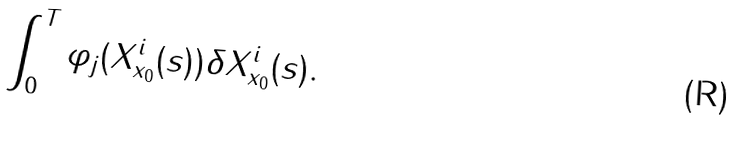<formula> <loc_0><loc_0><loc_500><loc_500>\int _ { 0 } ^ { T } \varphi _ { j } ( X _ { x _ { 0 } } ^ { i } ( s ) ) \delta X _ { x _ { 0 } } ^ { i } ( s ) .</formula> 